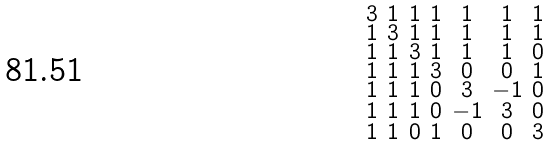<formula> <loc_0><loc_0><loc_500><loc_500>\begin{smallmatrix} 3 & 1 & 1 & 1 & 1 & 1 & 1 \\ 1 & 3 & 1 & 1 & 1 & 1 & 1 \\ 1 & 1 & 3 & 1 & 1 & 1 & 0 \\ 1 & 1 & 1 & 3 & 0 & 0 & 1 \\ 1 & 1 & 1 & 0 & 3 & - 1 & 0 \\ 1 & 1 & 1 & 0 & - 1 & 3 & 0 \\ 1 & 1 & 0 & 1 & 0 & 0 & 3 \end{smallmatrix}</formula> 